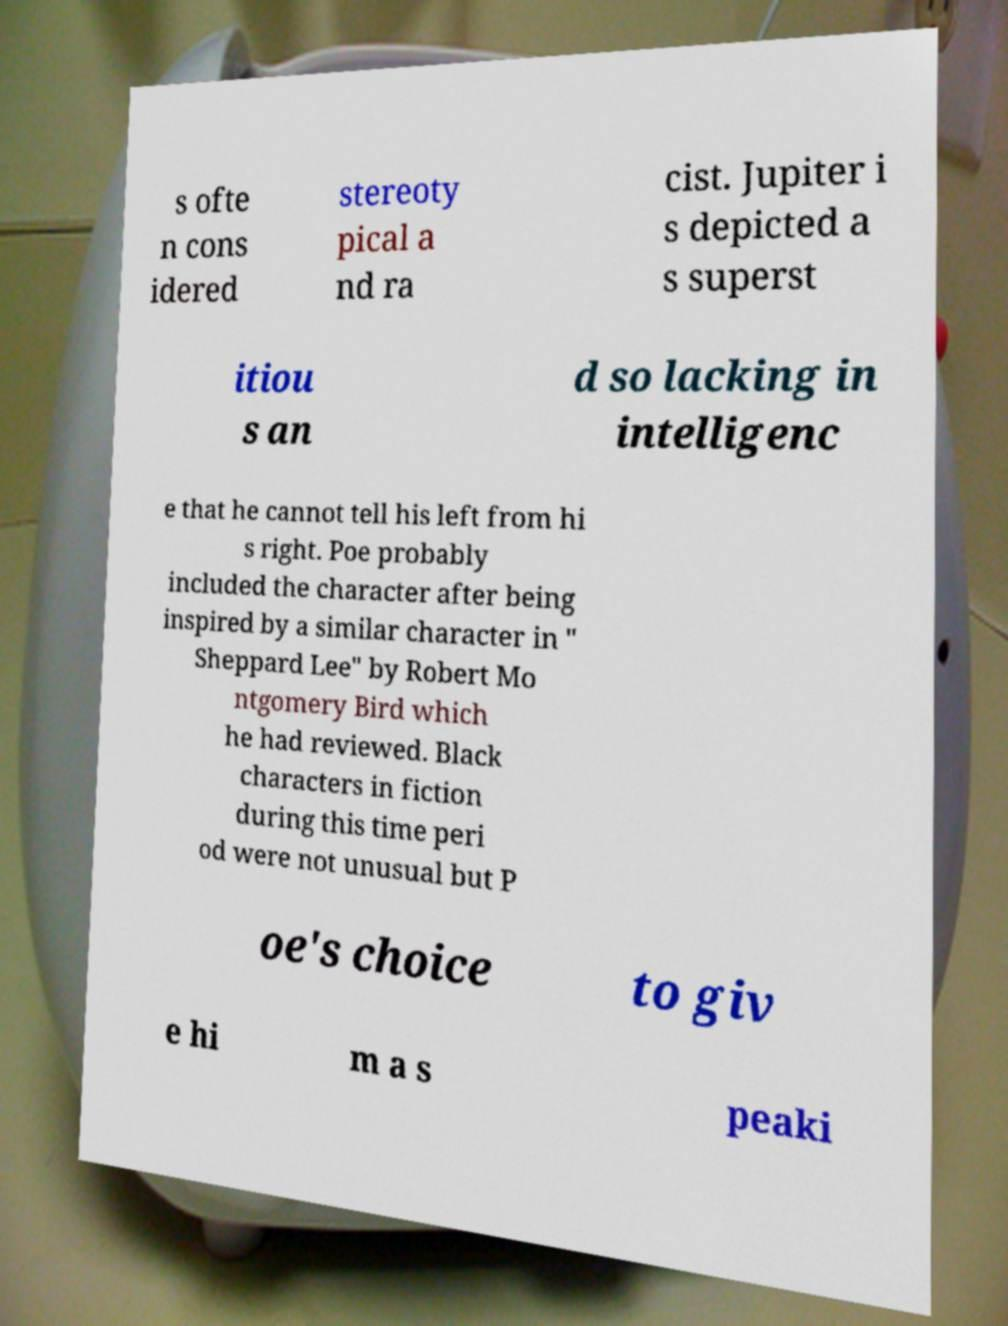Please identify and transcribe the text found in this image. s ofte n cons idered stereoty pical a nd ra cist. Jupiter i s depicted a s superst itiou s an d so lacking in intelligenc e that he cannot tell his left from hi s right. Poe probably included the character after being inspired by a similar character in " Sheppard Lee" by Robert Mo ntgomery Bird which he had reviewed. Black characters in fiction during this time peri od were not unusual but P oe's choice to giv e hi m a s peaki 